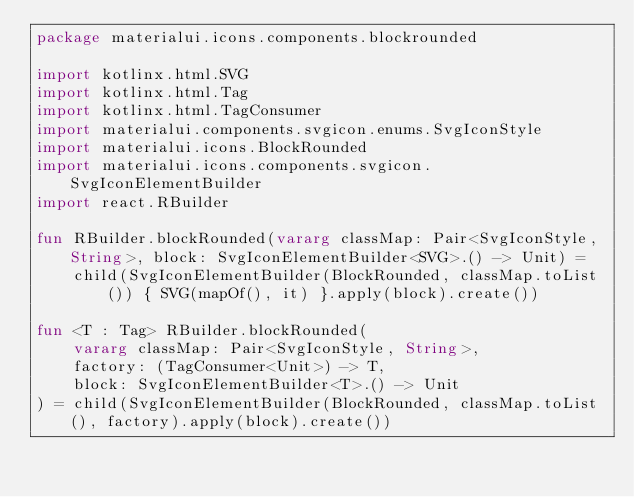<code> <loc_0><loc_0><loc_500><loc_500><_Kotlin_>package materialui.icons.components.blockrounded

import kotlinx.html.SVG
import kotlinx.html.Tag
import kotlinx.html.TagConsumer
import materialui.components.svgicon.enums.SvgIconStyle
import materialui.icons.BlockRounded
import materialui.icons.components.svgicon.SvgIconElementBuilder
import react.RBuilder

fun RBuilder.blockRounded(vararg classMap: Pair<SvgIconStyle, String>, block: SvgIconElementBuilder<SVG>.() -> Unit) =
    child(SvgIconElementBuilder(BlockRounded, classMap.toList()) { SVG(mapOf(), it) }.apply(block).create())

fun <T : Tag> RBuilder.blockRounded(
    vararg classMap: Pair<SvgIconStyle, String>,
    factory: (TagConsumer<Unit>) -> T,
    block: SvgIconElementBuilder<T>.() -> Unit
) = child(SvgIconElementBuilder(BlockRounded, classMap.toList(), factory).apply(block).create())
</code> 